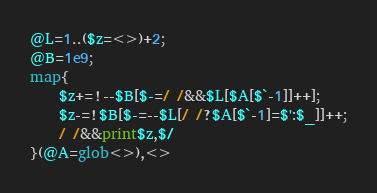<code> <loc_0><loc_0><loc_500><loc_500><_Perl_>@L=1..($z=<>)+2;
@B=1e9;
map{
	$z+=!--$B[$-=/ /&&$L[$A[$`-1]]++];
	$z-=!$B[$-=--$L[/ /?$A[$`-1]=$':$_]]++;
	/ /&&print$z,$/
}(@A=glob<>),<>
</code> 